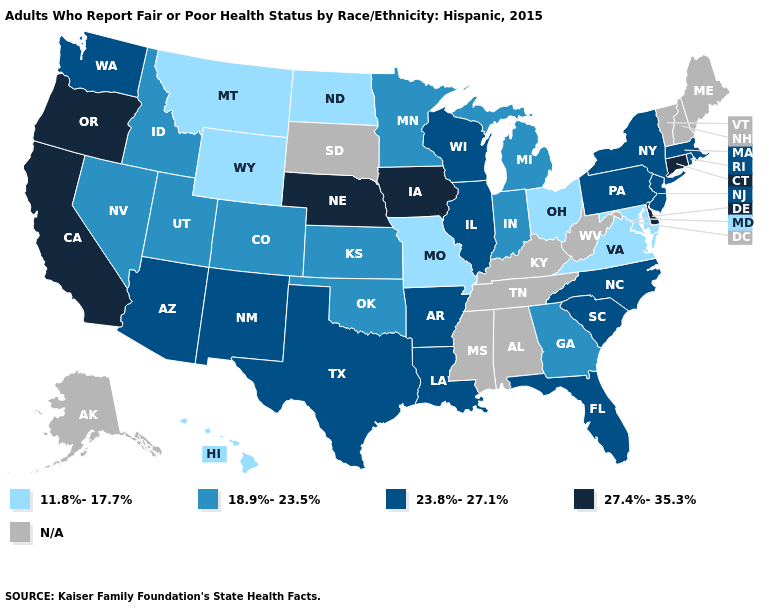Among the states that border Ohio , does Michigan have the highest value?
Write a very short answer. No. Does the map have missing data?
Quick response, please. Yes. What is the highest value in the Northeast ?
Be succinct. 27.4%-35.3%. Does the map have missing data?
Short answer required. Yes. Does the first symbol in the legend represent the smallest category?
Keep it brief. Yes. Which states have the lowest value in the Northeast?
Short answer required. Massachusetts, New Jersey, New York, Pennsylvania, Rhode Island. Does Connecticut have the highest value in the USA?
Answer briefly. Yes. Does the map have missing data?
Short answer required. Yes. Does the map have missing data?
Keep it brief. Yes. Name the states that have a value in the range 27.4%-35.3%?
Concise answer only. California, Connecticut, Delaware, Iowa, Nebraska, Oregon. What is the highest value in the USA?
Short answer required. 27.4%-35.3%. Does Virginia have the lowest value in the South?
Quick response, please. Yes. Name the states that have a value in the range N/A?
Short answer required. Alabama, Alaska, Kentucky, Maine, Mississippi, New Hampshire, South Dakota, Tennessee, Vermont, West Virginia. 